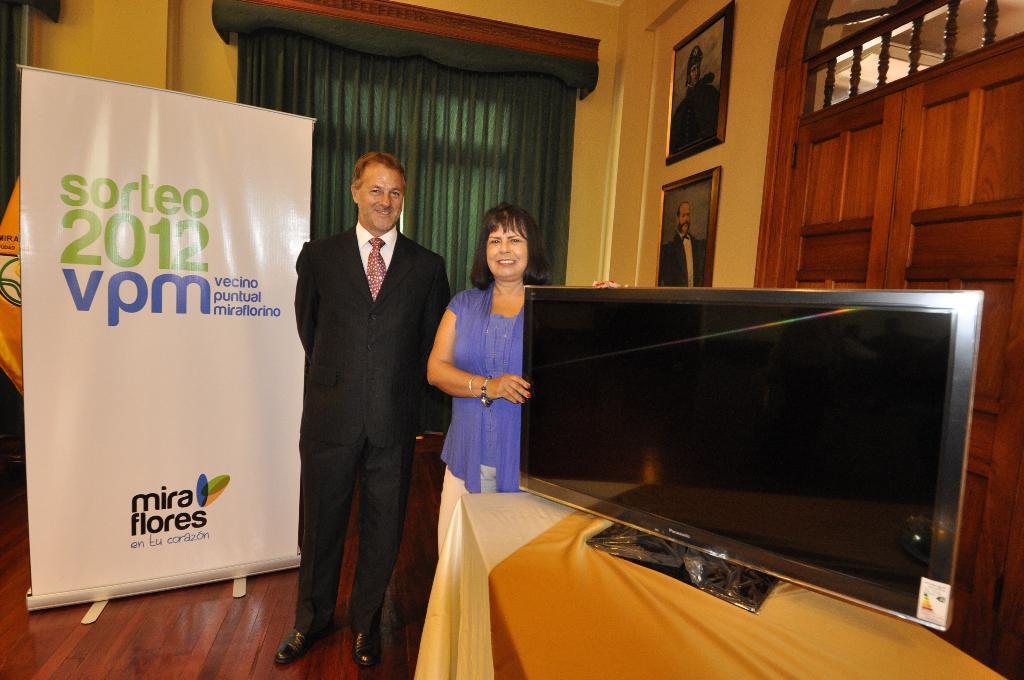Could you give a brief overview of what you see in this image? In this image there is a couple in the middle. The woman on the right side is holding the television which is on the table. On the left side there is a banner. In the background there is a wall on which there are two photo frames. On the right side behind the television there is a door. 